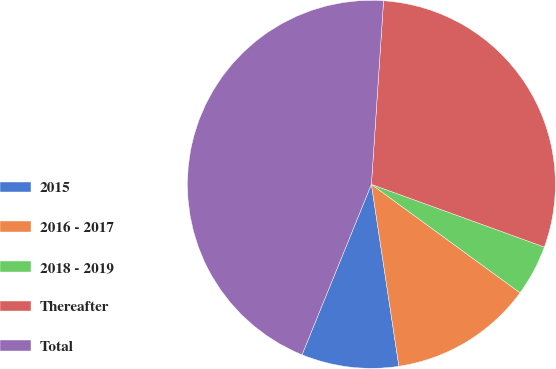<chart> <loc_0><loc_0><loc_500><loc_500><pie_chart><fcel>2015<fcel>2016 - 2017<fcel>2018 - 2019<fcel>Thereafter<fcel>Total<nl><fcel>8.54%<fcel>12.58%<fcel>4.5%<fcel>29.48%<fcel>44.9%<nl></chart> 